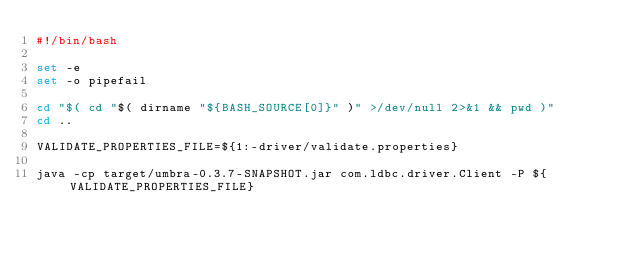Convert code to text. <code><loc_0><loc_0><loc_500><loc_500><_Bash_>#!/bin/bash

set -e
set -o pipefail

cd "$( cd "$( dirname "${BASH_SOURCE[0]}" )" >/dev/null 2>&1 && pwd )"
cd ..

VALIDATE_PROPERTIES_FILE=${1:-driver/validate.properties}

java -cp target/umbra-0.3.7-SNAPSHOT.jar com.ldbc.driver.Client -P ${VALIDATE_PROPERTIES_FILE}
</code> 